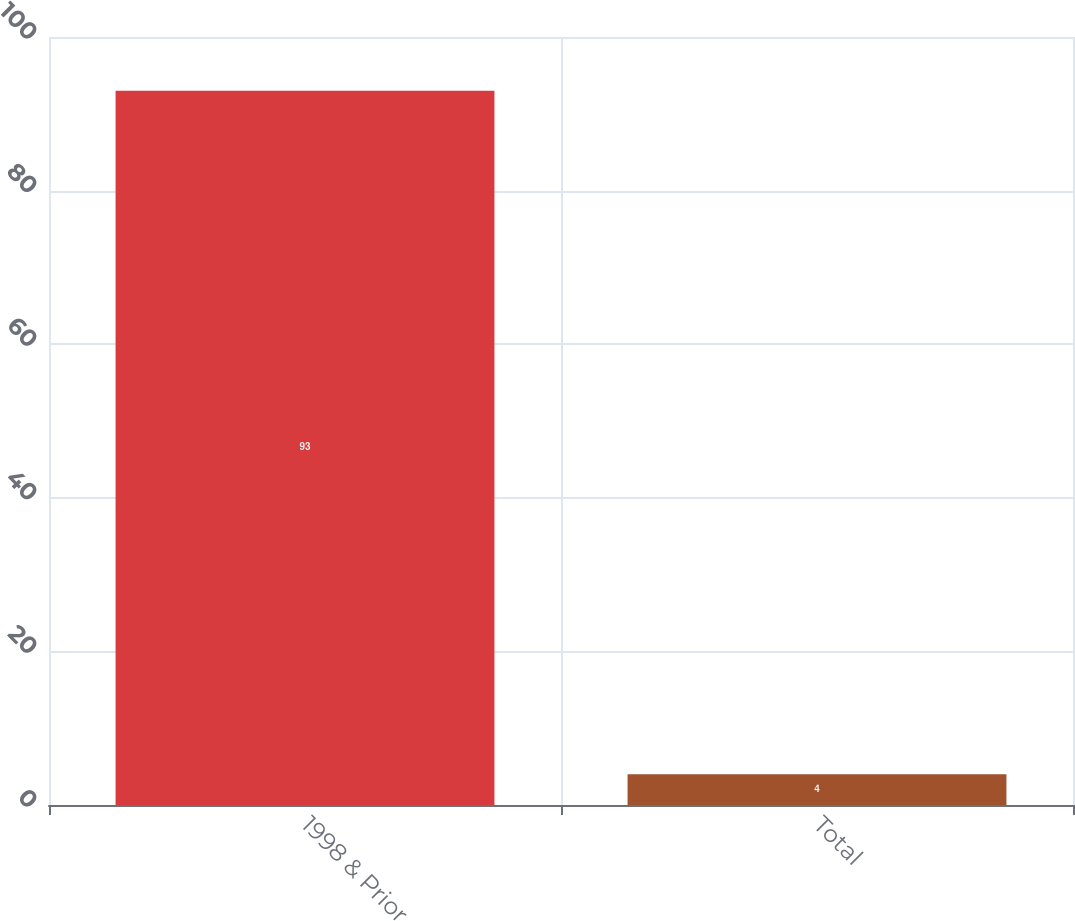Convert chart to OTSL. <chart><loc_0><loc_0><loc_500><loc_500><bar_chart><fcel>1998 & Prior<fcel>Total<nl><fcel>93<fcel>4<nl></chart> 